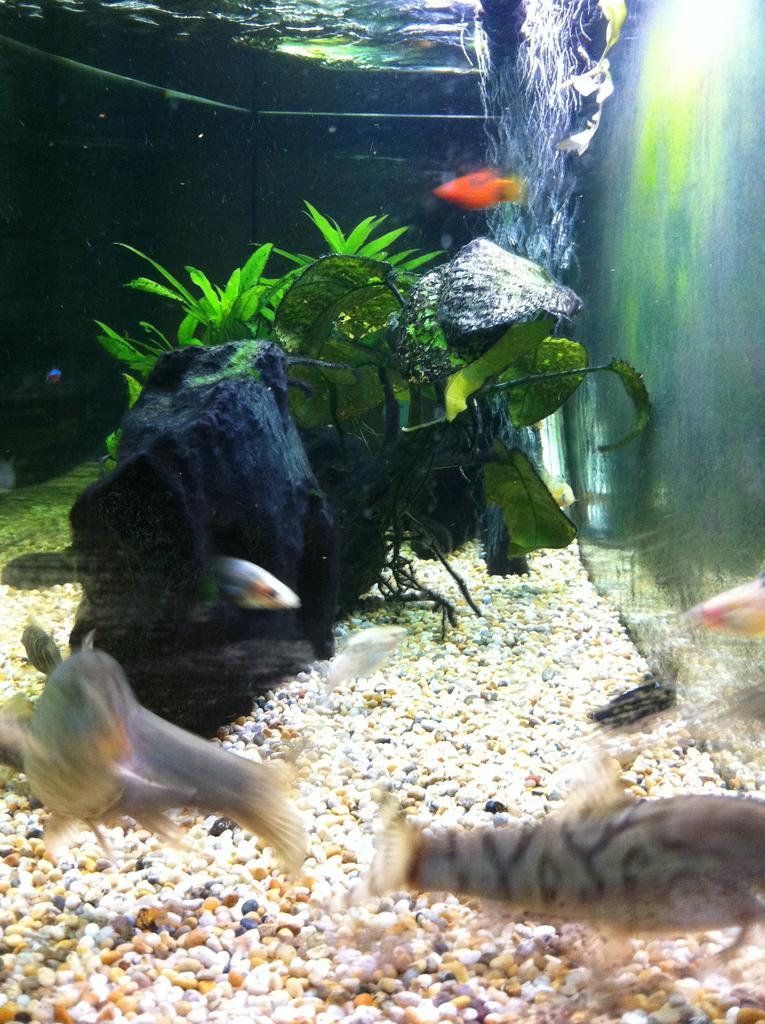Describe this image in one or two sentences. There are fishes, a plant, water and pebbles in an aquarium. 